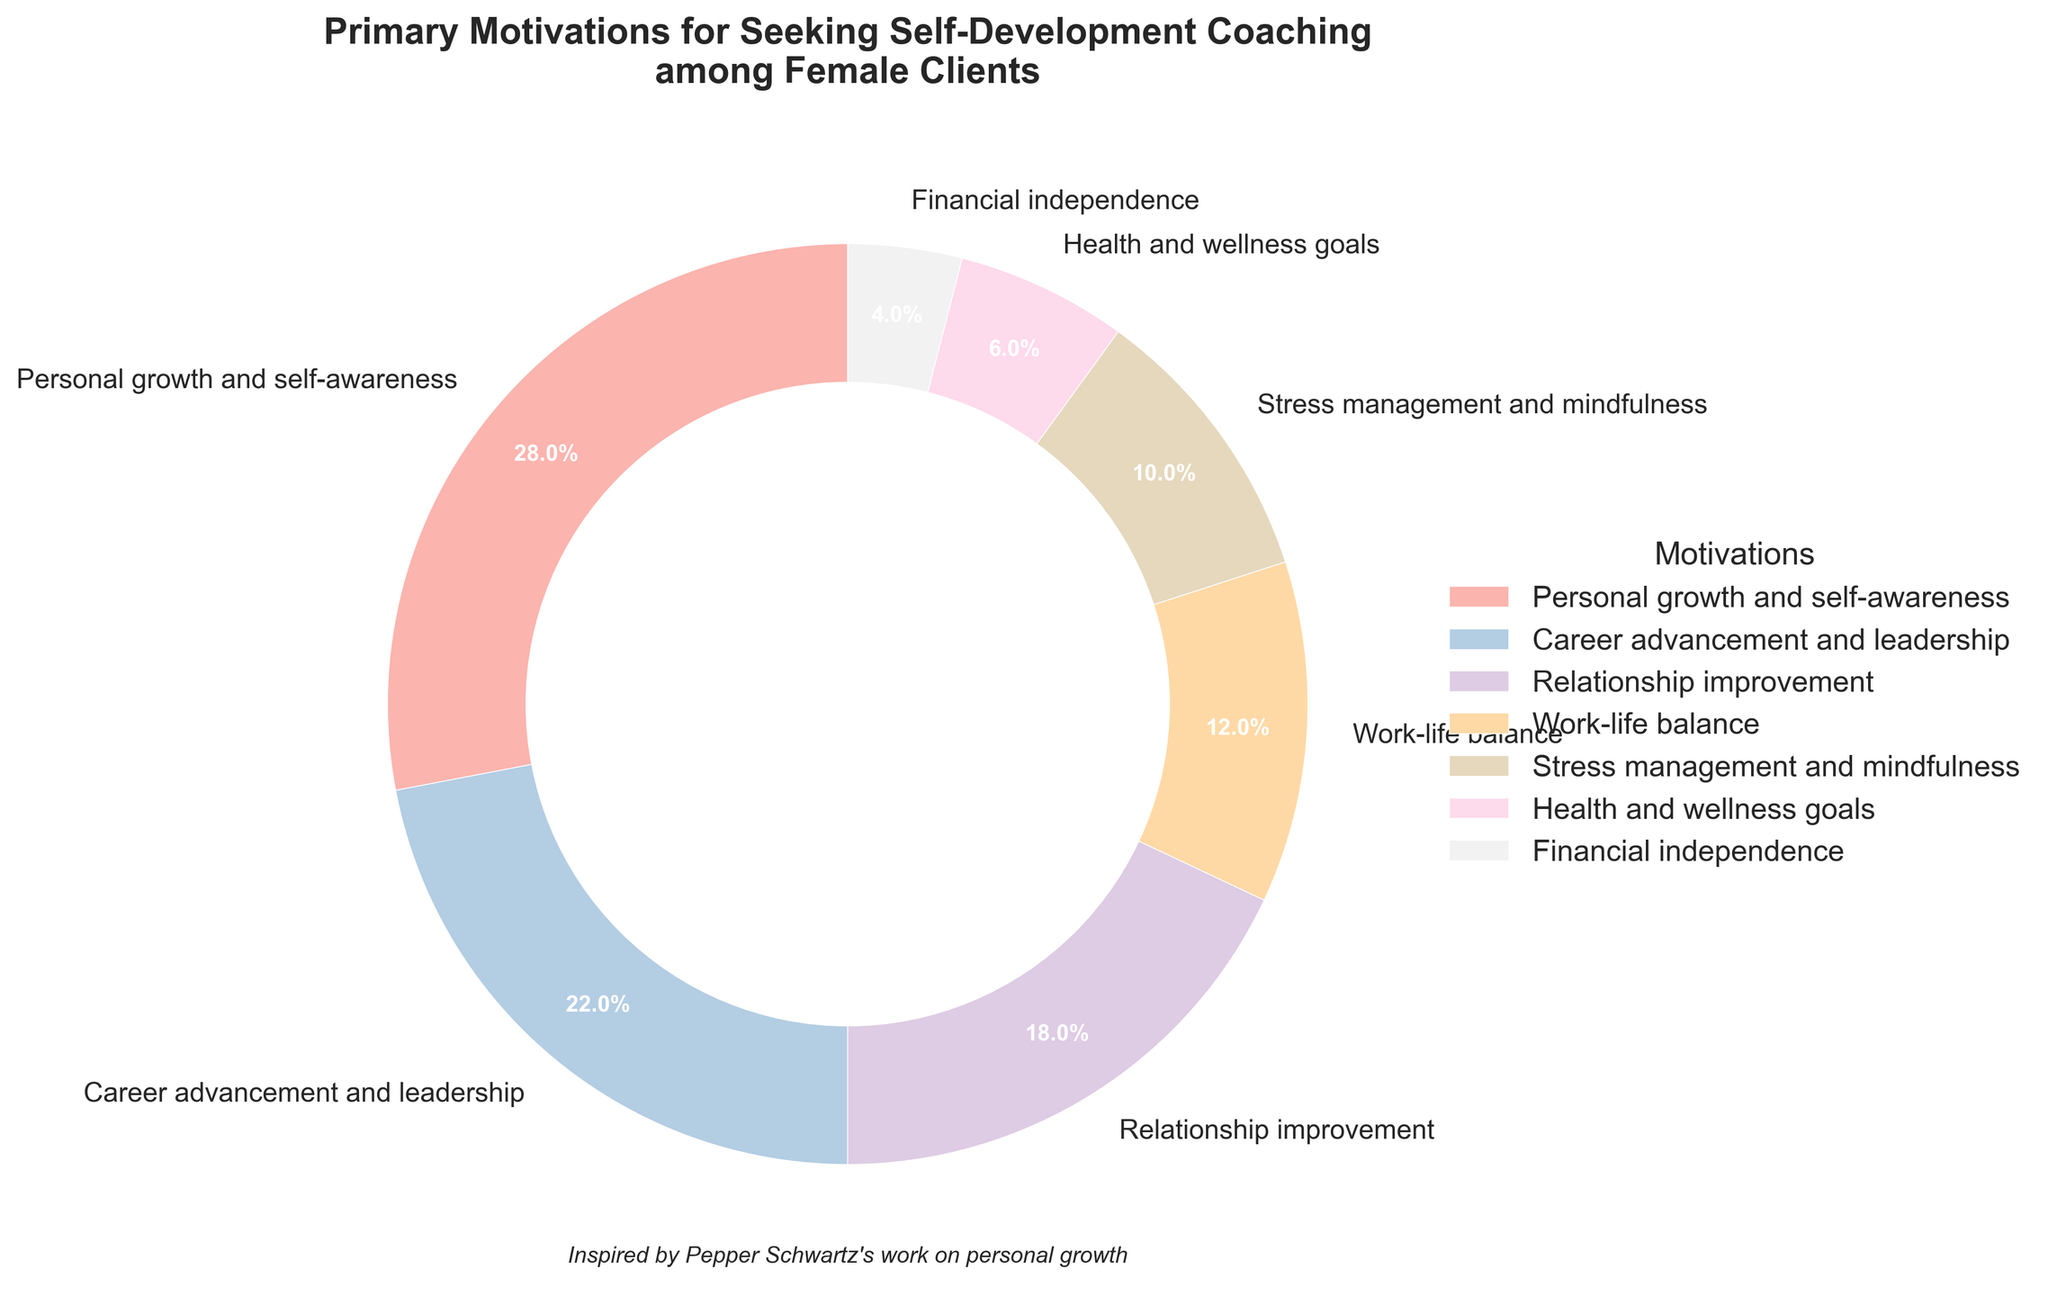What is the primary motivation for seeking self-development coaching among female clients based on the chart? Look at the slice with the highest percentage. The largest slice represents "Personal growth and self-awareness" at 28%.
Answer: Personal growth and self-awareness Which motivation has a higher percentage, career advancement and leadership, or relationship improvement? Compare the slices representing "Career advancement and leadership" and "Relationship improvement". "Career advancement and leadership" is 22%, higher than "Relationship improvement" at 18%.
Answer: Career advancement and leadership What is the combined percentage for stress management and mindfulness and health and wellness goals? Identify the slices for "Stress management and mindfulness" and "Health and wellness goals". Add their percentages: 10% + 6%.
Answer: 16% What is the difference in percentage points between work-life balance and financial independence? Identify the slices for "Work-life balance" and "Financial independence". Subtract the smaller percentage from the larger one: 12% - 4%.
Answer: 8% Which motivation has the smallest percentage, and what is its value? Look for the smallest slice which represents "Financial independence" with a value of 4%.
Answer: Financial independence, 4% How many motivations have a percentage higher than 15%? List the slices with more than 15%: "Personal growth and self-awareness" (28%), "Career advancement and leadership" (22%), and "Relationship improvement" (18%). Count them.
Answer: 3 Does the combined percentage of relationship improvement, work-life balance, and stress management and mindfulness exceed that of personal growth and self-awareness? Sum the percentages of "Relationship improvement" (18%), "Work-life balance" (12%), and "Stress management and mindfulness" (10%). Compare it with "Personal growth and self-awareness" (28%): 18% + 12% + 10% = 40%, which is greater than 28%.
Answer: Yes What is the average percentage for all the motivations presented? Add all percentages: 28% + 22% + 18% + 12% + 10% + 6% + 4% = 100%. Since there are 7 categories, divide the sum by 7: 100% / 7.
Answer: Approximately 14.3% Which color represents career advancement and leadership in the chart? Identify the visual attribute of color for "Career advancement and leadership" on the pie chart. This is often depicted by a specific color in the legend. Based on typical color schemes, you need to look at the chart for this color.
Answer: Pastel color, specific color based on chart legend Between health and wellness goals and financial independence, which motivation is visually represented by a larger slice? Compare the slices for "Health and wellness goals" and "Financial independence". The slice for "Health and wellness goals" is 6%, larger than "Financial independence" which is 4%.
Answer: Health and wellness goals 